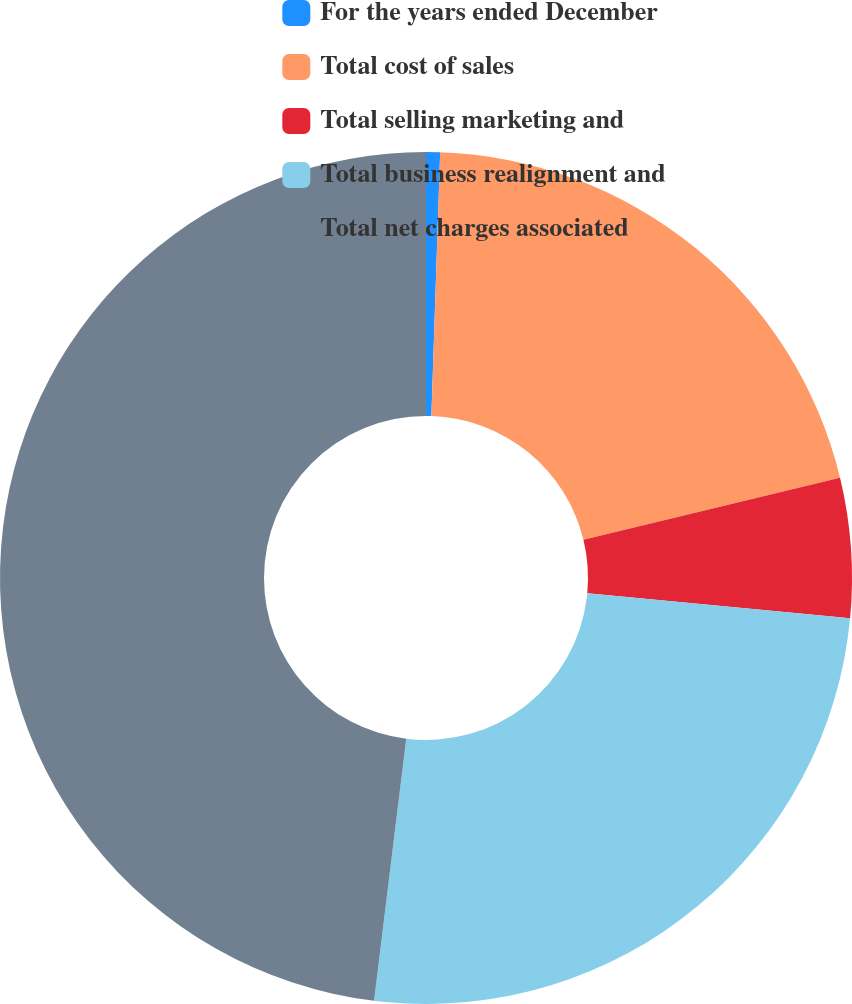Convert chart to OTSL. <chart><loc_0><loc_0><loc_500><loc_500><pie_chart><fcel>For the years ended December<fcel>Total cost of sales<fcel>Total selling marketing and<fcel>Total business realignment and<fcel>Total net charges associated<nl><fcel>0.53%<fcel>20.69%<fcel>5.29%<fcel>25.44%<fcel>48.06%<nl></chart> 